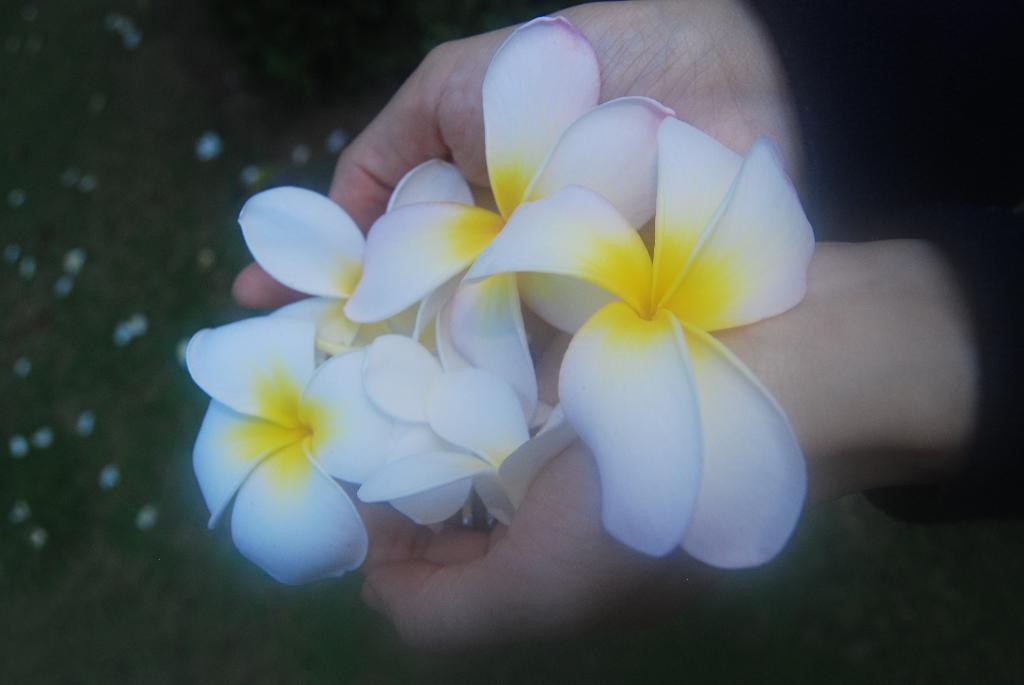Who is present in the image? There is a person in the image. What is the person wearing? The person is wearing a black dress. What is the person holding in the image? The person is holding flowers. Can you describe the flowers? The flowers have a white and yellow color combination. What else can be seen in the background of the image? There are other objects in the background of the image. What type of cheese is being served on the stage in the image? There is no cheese or stage present in the image. Is the person wearing a veil in the image? The provided facts do not mention a veil, so we cannot determine if the person is wearing one. 